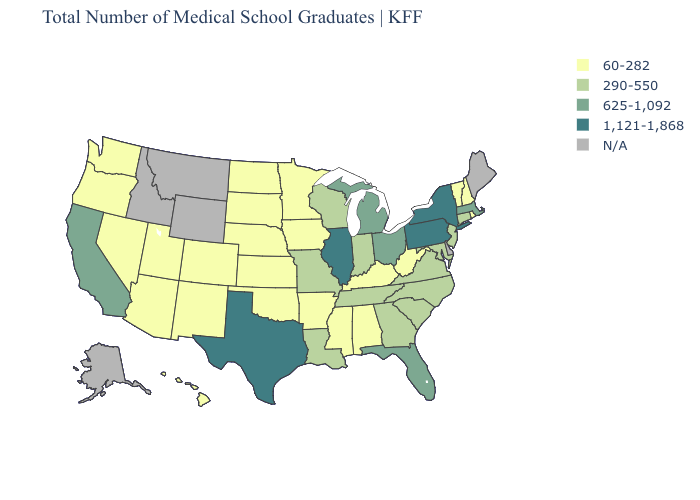What is the highest value in the West ?
Be succinct. 625-1,092. Name the states that have a value in the range 1,121-1,868?
Keep it brief. Illinois, New York, Pennsylvania, Texas. Name the states that have a value in the range 290-550?
Write a very short answer. Connecticut, Georgia, Indiana, Louisiana, Maryland, Missouri, New Jersey, North Carolina, South Carolina, Tennessee, Virginia, Wisconsin. What is the value of Louisiana?
Be succinct. 290-550. Which states have the lowest value in the USA?
Be succinct. Alabama, Arizona, Arkansas, Colorado, Hawaii, Iowa, Kansas, Kentucky, Minnesota, Mississippi, Nebraska, Nevada, New Hampshire, New Mexico, North Dakota, Oklahoma, Oregon, Rhode Island, South Dakota, Utah, Vermont, Washington, West Virginia. Name the states that have a value in the range N/A?
Concise answer only. Alaska, Delaware, Idaho, Maine, Montana, Wyoming. Which states have the lowest value in the USA?
Write a very short answer. Alabama, Arizona, Arkansas, Colorado, Hawaii, Iowa, Kansas, Kentucky, Minnesota, Mississippi, Nebraska, Nevada, New Hampshire, New Mexico, North Dakota, Oklahoma, Oregon, Rhode Island, South Dakota, Utah, Vermont, Washington, West Virginia. Name the states that have a value in the range 60-282?
Keep it brief. Alabama, Arizona, Arkansas, Colorado, Hawaii, Iowa, Kansas, Kentucky, Minnesota, Mississippi, Nebraska, Nevada, New Hampshire, New Mexico, North Dakota, Oklahoma, Oregon, Rhode Island, South Dakota, Utah, Vermont, Washington, West Virginia. Which states have the lowest value in the USA?
Short answer required. Alabama, Arizona, Arkansas, Colorado, Hawaii, Iowa, Kansas, Kentucky, Minnesota, Mississippi, Nebraska, Nevada, New Hampshire, New Mexico, North Dakota, Oklahoma, Oregon, Rhode Island, South Dakota, Utah, Vermont, Washington, West Virginia. Among the states that border Kansas , does Nebraska have the highest value?
Quick response, please. No. What is the lowest value in the South?
Write a very short answer. 60-282. What is the value of Kansas?
Concise answer only. 60-282. 